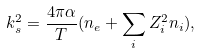Convert formula to latex. <formula><loc_0><loc_0><loc_500><loc_500>k ^ { 2 } _ { s } = \frac { 4 \pi \alpha } { T } ( n _ { e } + \sum _ { i } Z ^ { 2 } _ { i } n _ { i } ) ,</formula> 